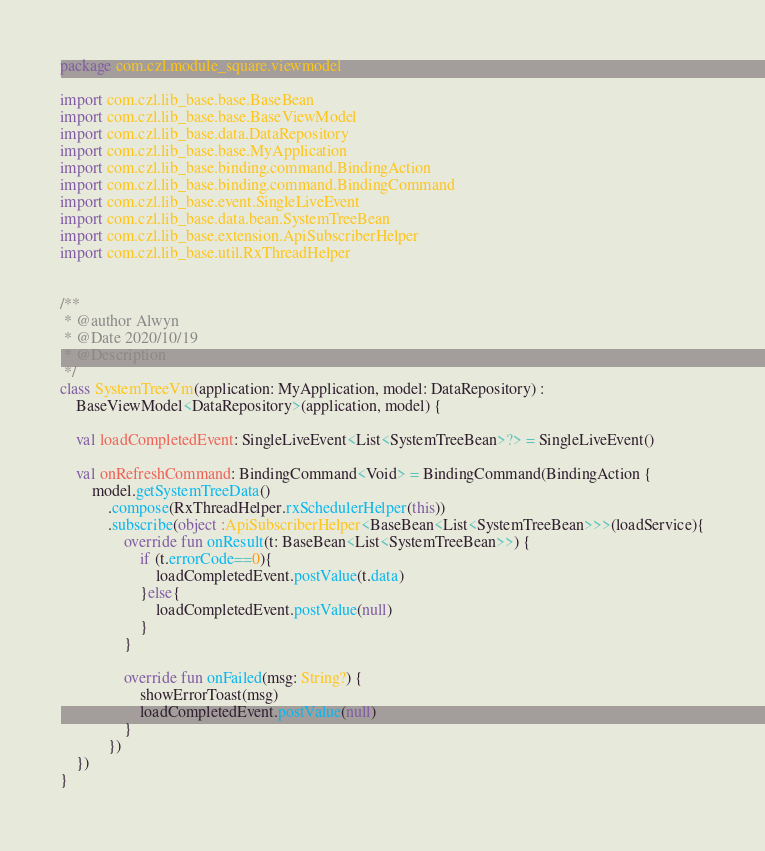<code> <loc_0><loc_0><loc_500><loc_500><_Kotlin_>package com.czl.module_square.viewmodel

import com.czl.lib_base.base.BaseBean
import com.czl.lib_base.base.BaseViewModel
import com.czl.lib_base.data.DataRepository
import com.czl.lib_base.base.MyApplication
import com.czl.lib_base.binding.command.BindingAction
import com.czl.lib_base.binding.command.BindingCommand
import com.czl.lib_base.event.SingleLiveEvent
import com.czl.lib_base.data.bean.SystemTreeBean
import com.czl.lib_base.extension.ApiSubscriberHelper
import com.czl.lib_base.util.RxThreadHelper


/**
 * @author Alwyn
 * @Date 2020/10/19
 * @Description
 */
class SystemTreeVm(application: MyApplication, model: DataRepository) :
    BaseViewModel<DataRepository>(application, model) {

    val loadCompletedEvent: SingleLiveEvent<List<SystemTreeBean>?> = SingleLiveEvent()

    val onRefreshCommand: BindingCommand<Void> = BindingCommand(BindingAction {
        model.getSystemTreeData()
            .compose(RxThreadHelper.rxSchedulerHelper(this))
            .subscribe(object :ApiSubscriberHelper<BaseBean<List<SystemTreeBean>>>(loadService){
                override fun onResult(t: BaseBean<List<SystemTreeBean>>) {
                    if (t.errorCode==0){
                        loadCompletedEvent.postValue(t.data)
                    }else{
                        loadCompletedEvent.postValue(null)
                    }
                }

                override fun onFailed(msg: String?) {
                    showErrorToast(msg)
                    loadCompletedEvent.postValue(null)
                }
            })
    })
}</code> 